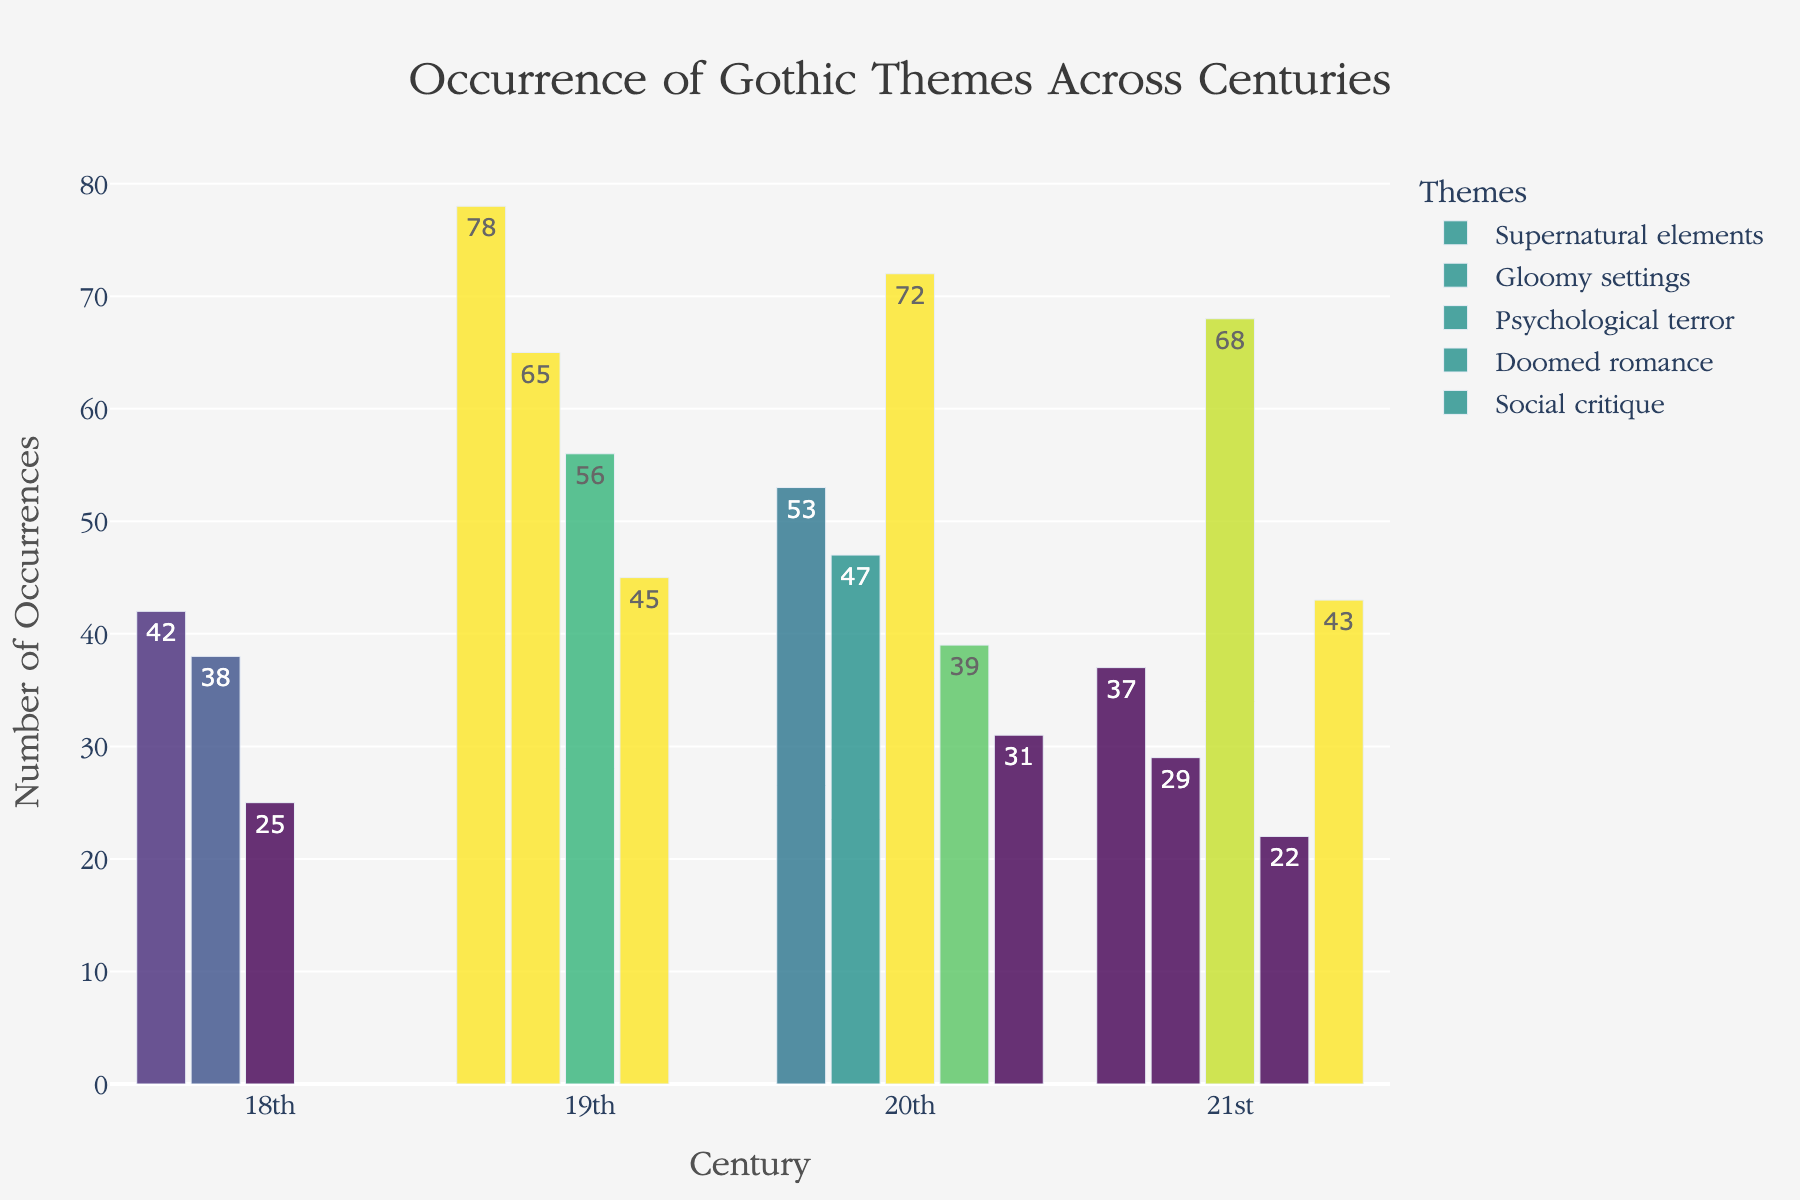How many Gothic themes are analyzed in the Histogram? The figure shows multiple color-coded bars, each representing a different Gothic theme. Counting the legend entries gives us the number of themes analyzed.
Answer: 5 Which theme was the most frequent in the 19th century? Look at the 19th-century group of bars and identify which bar reaches the highest value. The legend or labels will tell which theme it represents.
Answer: Supernatural elements What is the total number of occurrences for "Doomed romance" across all centuries? Sum the occurrences of "Doomed romance" from each century: 19th (45) + 20th (39) + 21st (22).
Answer: 106 Which century had the highest overall count of occurrences? Sum the occurrences for each century and compare. For the 18th: 42+38+25 = 105. For the 19th: 78+65+56+45 = 244. For the 20th: 53+47+72+39+31 = 242. For the 21st: 37+29+68+22+43 = 199.
Answer: 19th century How many more times does "Psychological terror" appear in the 20th century than in the 21st century? Subtract the occurrence of "Psychological terror" in the 21st century (68) from the 20th century (72).
Answer: 4 In which century did "Social critique" first appear? Examine the bars for "Social critique" and identify the earliest century among them.
Answer: 20th century Which theme saw a decrease in occurrences from the 19th to the 20th century? Compare the heights of the bars for each theme between the 19th and 20th centuries. Look for themes which have shorter bars in the 20th compared to the 19th.
Answer: Doomed romance What is the average number of occurrences for "Gloomy settings" across all centuries? Sum the occurrences of "Gloomy settings" ( 38+65+47+29) and divide by the number of centuries they appear in. 38+65+47+29 = 179; 179/4 = 44.75.
Answer: 44.75 By how much did the occurrences of "Supernatural elements" change from the 18th to the 21st century? Subtract the occurrences of the 21st century (37) from the 18th century (42).
Answer: -5 